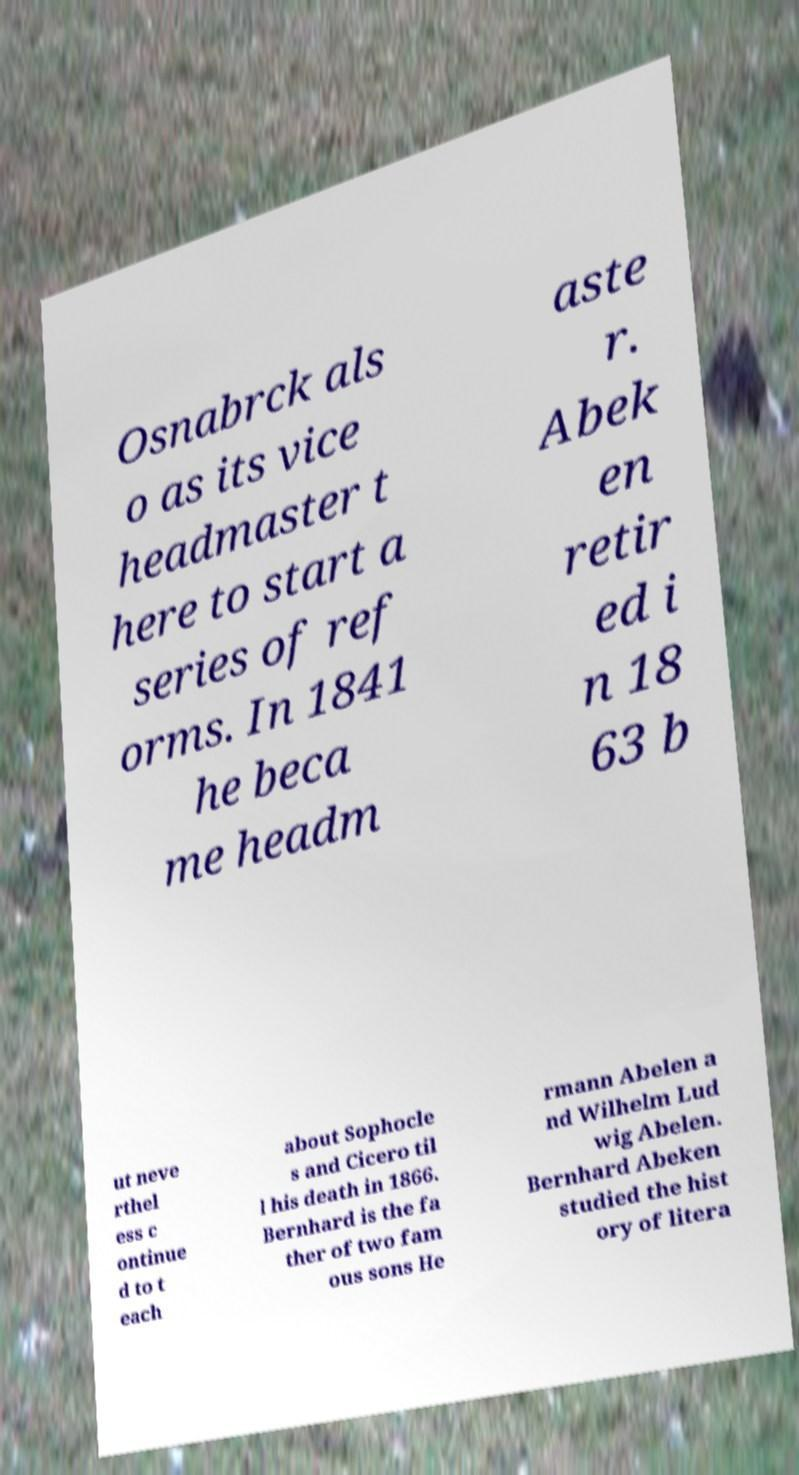What messages or text are displayed in this image? I need them in a readable, typed format. Osnabrck als o as its vice headmaster t here to start a series of ref orms. In 1841 he beca me headm aste r. Abek en retir ed i n 18 63 b ut neve rthel ess c ontinue d to t each about Sophocle s and Cicero til l his death in 1866. Bernhard is the fa ther of two fam ous sons He rmann Abelen a nd Wilhelm Lud wig Abelen. Bernhard Abeken studied the hist ory of litera 